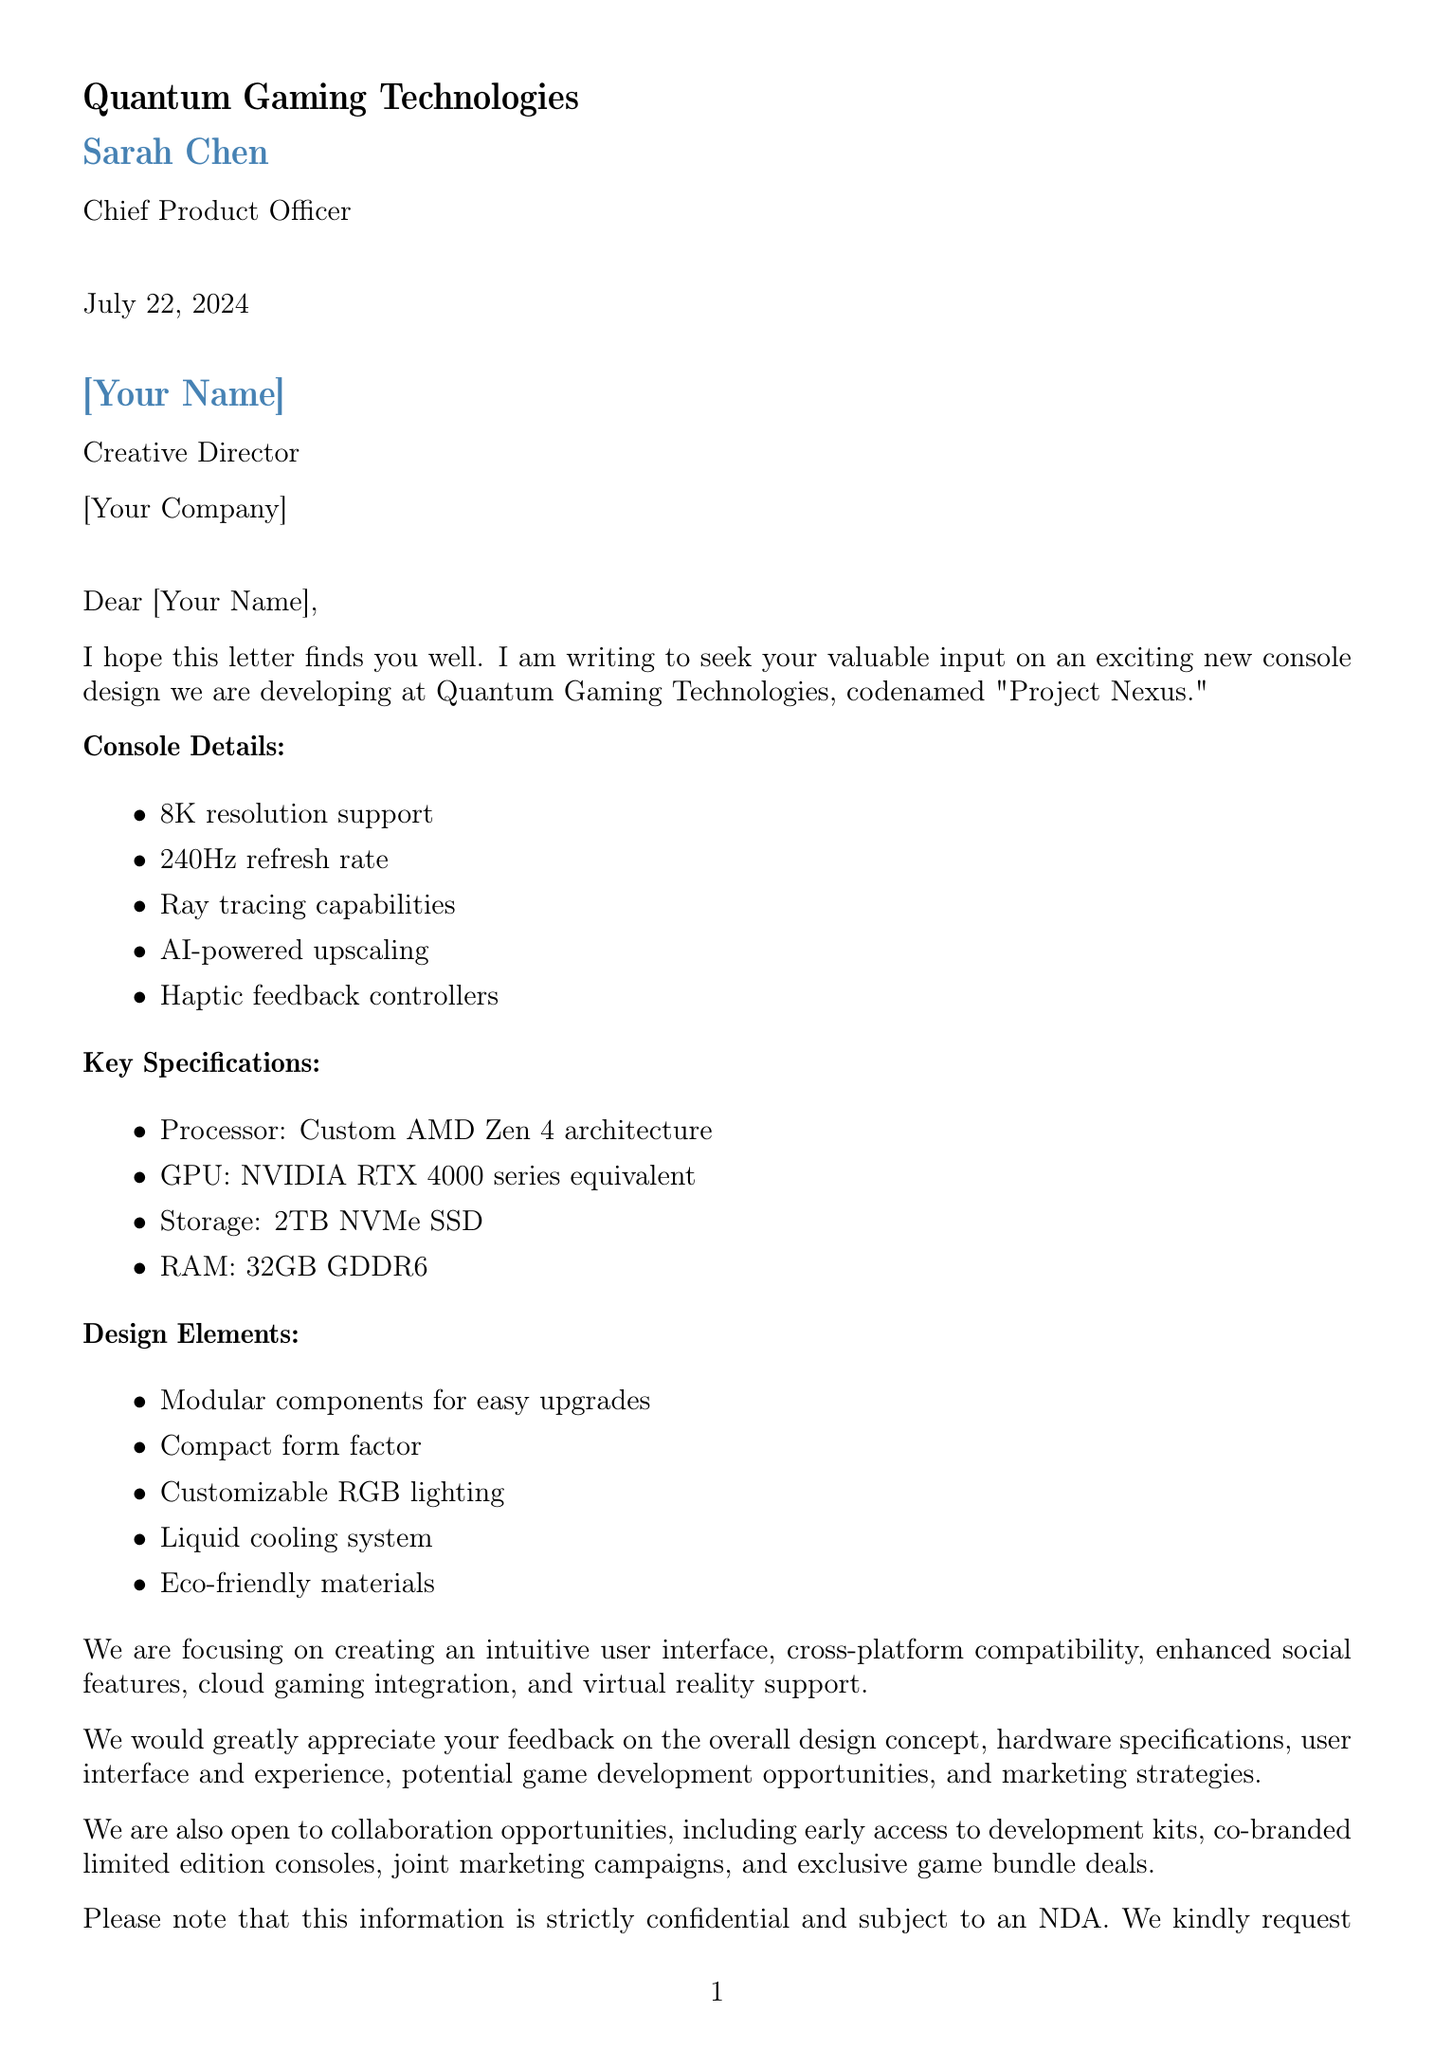What is the codename of the new console? The codename for the new console is mentioned in the document as "Project Nexus."
Answer: Project Nexus Who is the Chief Product Officer of Quantum Gaming Technologies? The document states that Sarah Chen is the Chief Product Officer.
Answer: Sarah Chen What is the target launch date for the console? The document specifies that the target launch date is Q4 next year.
Answer: Q4 next year How much storage does the console have? The document lists the storage capacity of the console as 2TB NVMe SSD.
Answer: 2TB NVMe SSD What are the key design elements mentioned? The document contains several design elements including "Modular components for easy upgrades."
Answer: Modular components for easy upgrades How long do they request feedback? The requested timeframe for feedback is 4 weeks from receipt of the document.
Answer: 4 weeks What type of agreement is required for confidentiality? The document mentions that a Non-Disclosure Agreement (NDA) is required for confidentiality.
Answer: NDA What is one of the collaboration opportunities listed? The document states that one of the collaboration opportunities includes "Early access to development kits."
Answer: Early access to development kits What main feature focuses on enhancing the gaming experience? One of the user experience focuses listed in the document is "Intuitive user interface."
Answer: Intuitive user interface 